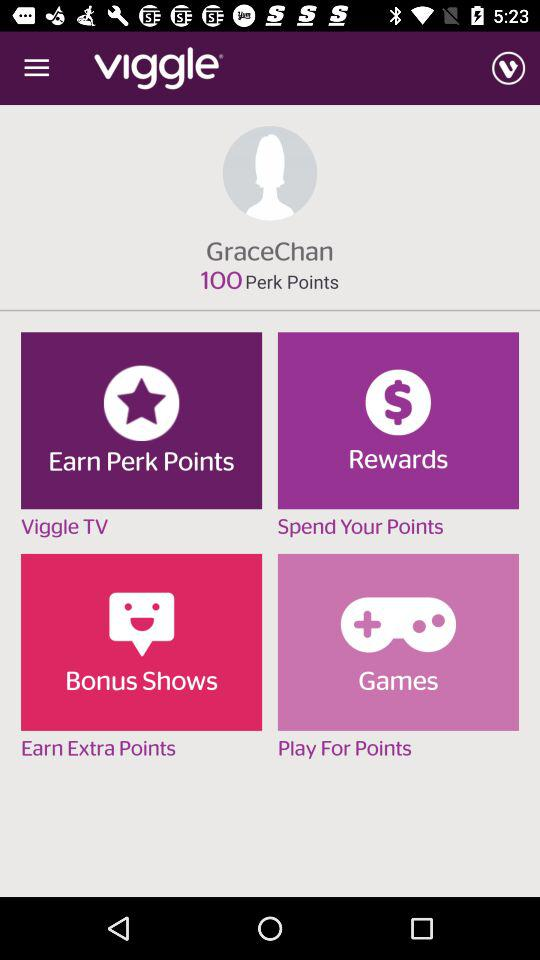What is the number of perk point? The number of perk points is 100. 